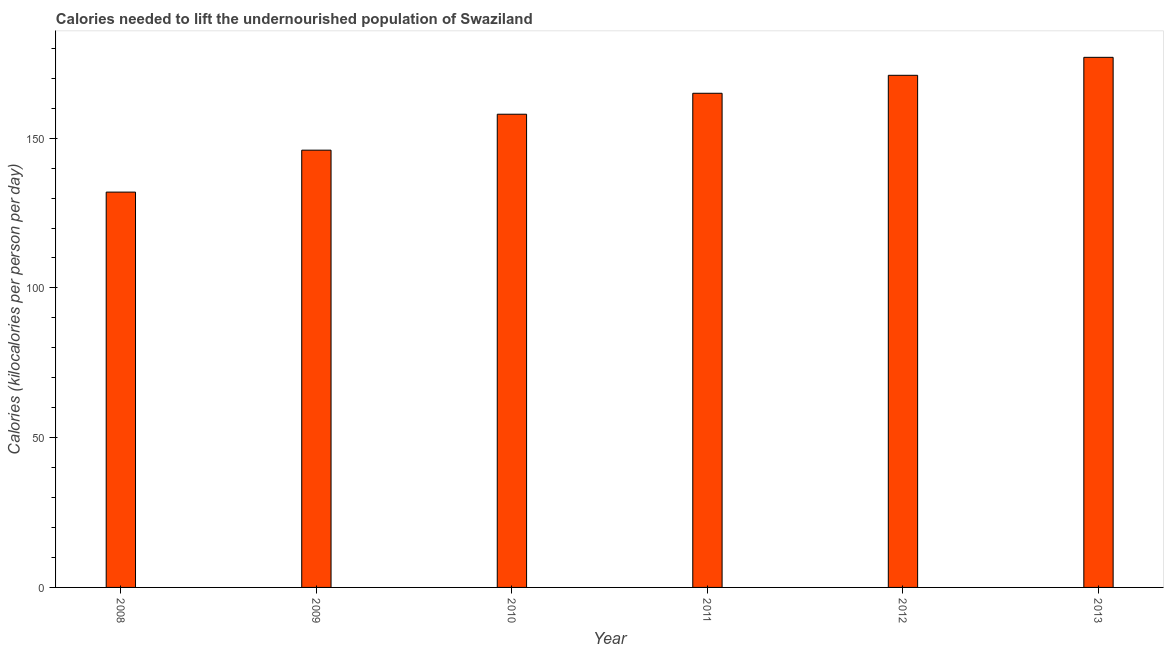What is the title of the graph?
Provide a short and direct response. Calories needed to lift the undernourished population of Swaziland. What is the label or title of the Y-axis?
Your answer should be compact. Calories (kilocalories per person per day). What is the depth of food deficit in 2008?
Offer a very short reply. 132. Across all years, what is the maximum depth of food deficit?
Your response must be concise. 177. Across all years, what is the minimum depth of food deficit?
Make the answer very short. 132. In which year was the depth of food deficit minimum?
Make the answer very short. 2008. What is the sum of the depth of food deficit?
Offer a terse response. 949. What is the difference between the depth of food deficit in 2008 and 2010?
Provide a succinct answer. -26. What is the average depth of food deficit per year?
Your answer should be very brief. 158. What is the median depth of food deficit?
Offer a terse response. 161.5. In how many years, is the depth of food deficit greater than 60 kilocalories?
Your response must be concise. 6. Do a majority of the years between 2008 and 2013 (inclusive) have depth of food deficit greater than 30 kilocalories?
Provide a succinct answer. Yes. What is the ratio of the depth of food deficit in 2009 to that in 2013?
Your answer should be compact. 0.82. What is the difference between the highest and the second highest depth of food deficit?
Offer a terse response. 6. Are all the bars in the graph horizontal?
Offer a very short reply. No. How many years are there in the graph?
Offer a terse response. 6. What is the Calories (kilocalories per person per day) in 2008?
Your response must be concise. 132. What is the Calories (kilocalories per person per day) of 2009?
Your response must be concise. 146. What is the Calories (kilocalories per person per day) in 2010?
Your response must be concise. 158. What is the Calories (kilocalories per person per day) of 2011?
Keep it short and to the point. 165. What is the Calories (kilocalories per person per day) in 2012?
Provide a succinct answer. 171. What is the Calories (kilocalories per person per day) in 2013?
Offer a terse response. 177. What is the difference between the Calories (kilocalories per person per day) in 2008 and 2011?
Provide a short and direct response. -33. What is the difference between the Calories (kilocalories per person per day) in 2008 and 2012?
Ensure brevity in your answer.  -39. What is the difference between the Calories (kilocalories per person per day) in 2008 and 2013?
Provide a succinct answer. -45. What is the difference between the Calories (kilocalories per person per day) in 2009 and 2010?
Ensure brevity in your answer.  -12. What is the difference between the Calories (kilocalories per person per day) in 2009 and 2012?
Keep it short and to the point. -25. What is the difference between the Calories (kilocalories per person per day) in 2009 and 2013?
Your response must be concise. -31. What is the difference between the Calories (kilocalories per person per day) in 2011 and 2012?
Provide a short and direct response. -6. What is the difference between the Calories (kilocalories per person per day) in 2011 and 2013?
Make the answer very short. -12. What is the ratio of the Calories (kilocalories per person per day) in 2008 to that in 2009?
Keep it short and to the point. 0.9. What is the ratio of the Calories (kilocalories per person per day) in 2008 to that in 2010?
Give a very brief answer. 0.83. What is the ratio of the Calories (kilocalories per person per day) in 2008 to that in 2011?
Offer a very short reply. 0.8. What is the ratio of the Calories (kilocalories per person per day) in 2008 to that in 2012?
Keep it short and to the point. 0.77. What is the ratio of the Calories (kilocalories per person per day) in 2008 to that in 2013?
Your answer should be compact. 0.75. What is the ratio of the Calories (kilocalories per person per day) in 2009 to that in 2010?
Offer a very short reply. 0.92. What is the ratio of the Calories (kilocalories per person per day) in 2009 to that in 2011?
Your answer should be very brief. 0.89. What is the ratio of the Calories (kilocalories per person per day) in 2009 to that in 2012?
Keep it short and to the point. 0.85. What is the ratio of the Calories (kilocalories per person per day) in 2009 to that in 2013?
Keep it short and to the point. 0.82. What is the ratio of the Calories (kilocalories per person per day) in 2010 to that in 2011?
Make the answer very short. 0.96. What is the ratio of the Calories (kilocalories per person per day) in 2010 to that in 2012?
Your answer should be compact. 0.92. What is the ratio of the Calories (kilocalories per person per day) in 2010 to that in 2013?
Make the answer very short. 0.89. What is the ratio of the Calories (kilocalories per person per day) in 2011 to that in 2012?
Your answer should be compact. 0.96. What is the ratio of the Calories (kilocalories per person per day) in 2011 to that in 2013?
Provide a short and direct response. 0.93. 